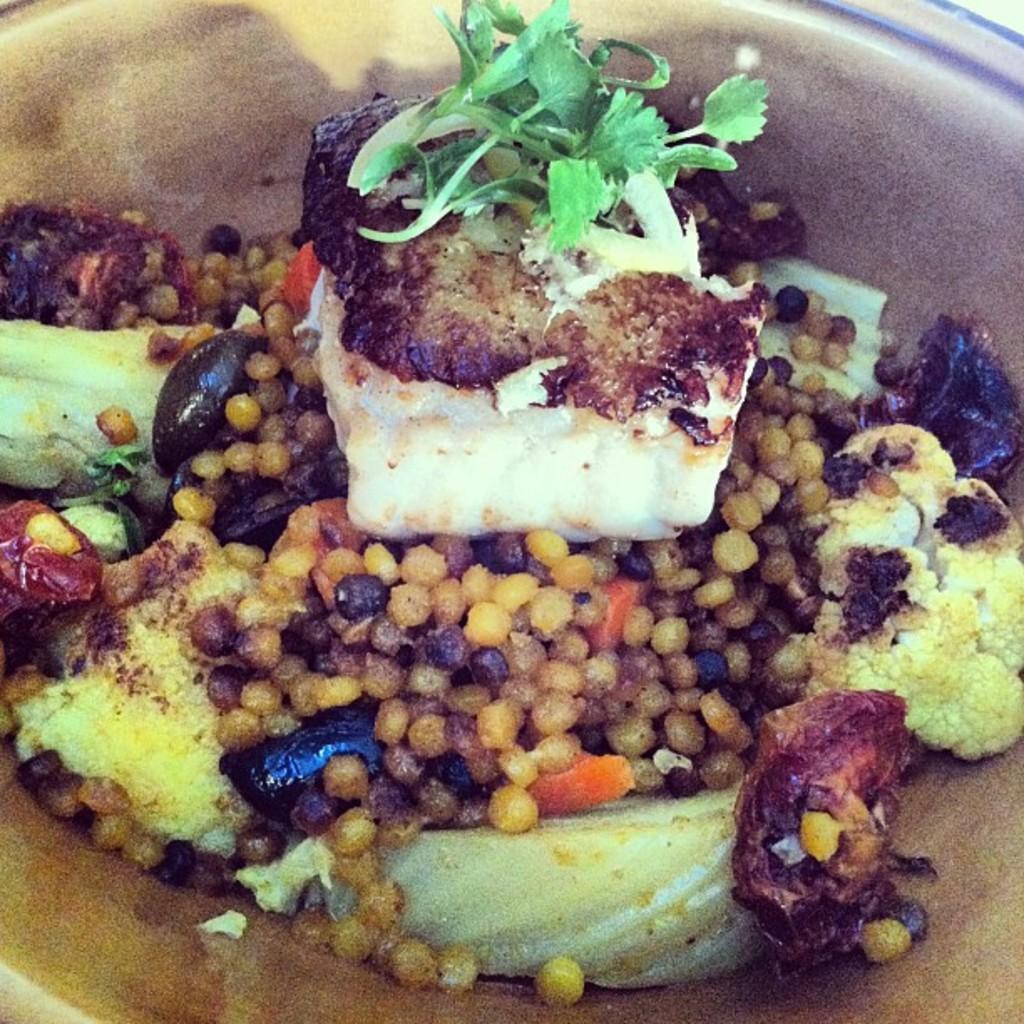Could you give a brief overview of what you see in this image? In this image there is a plate, in that place there is a food item. 